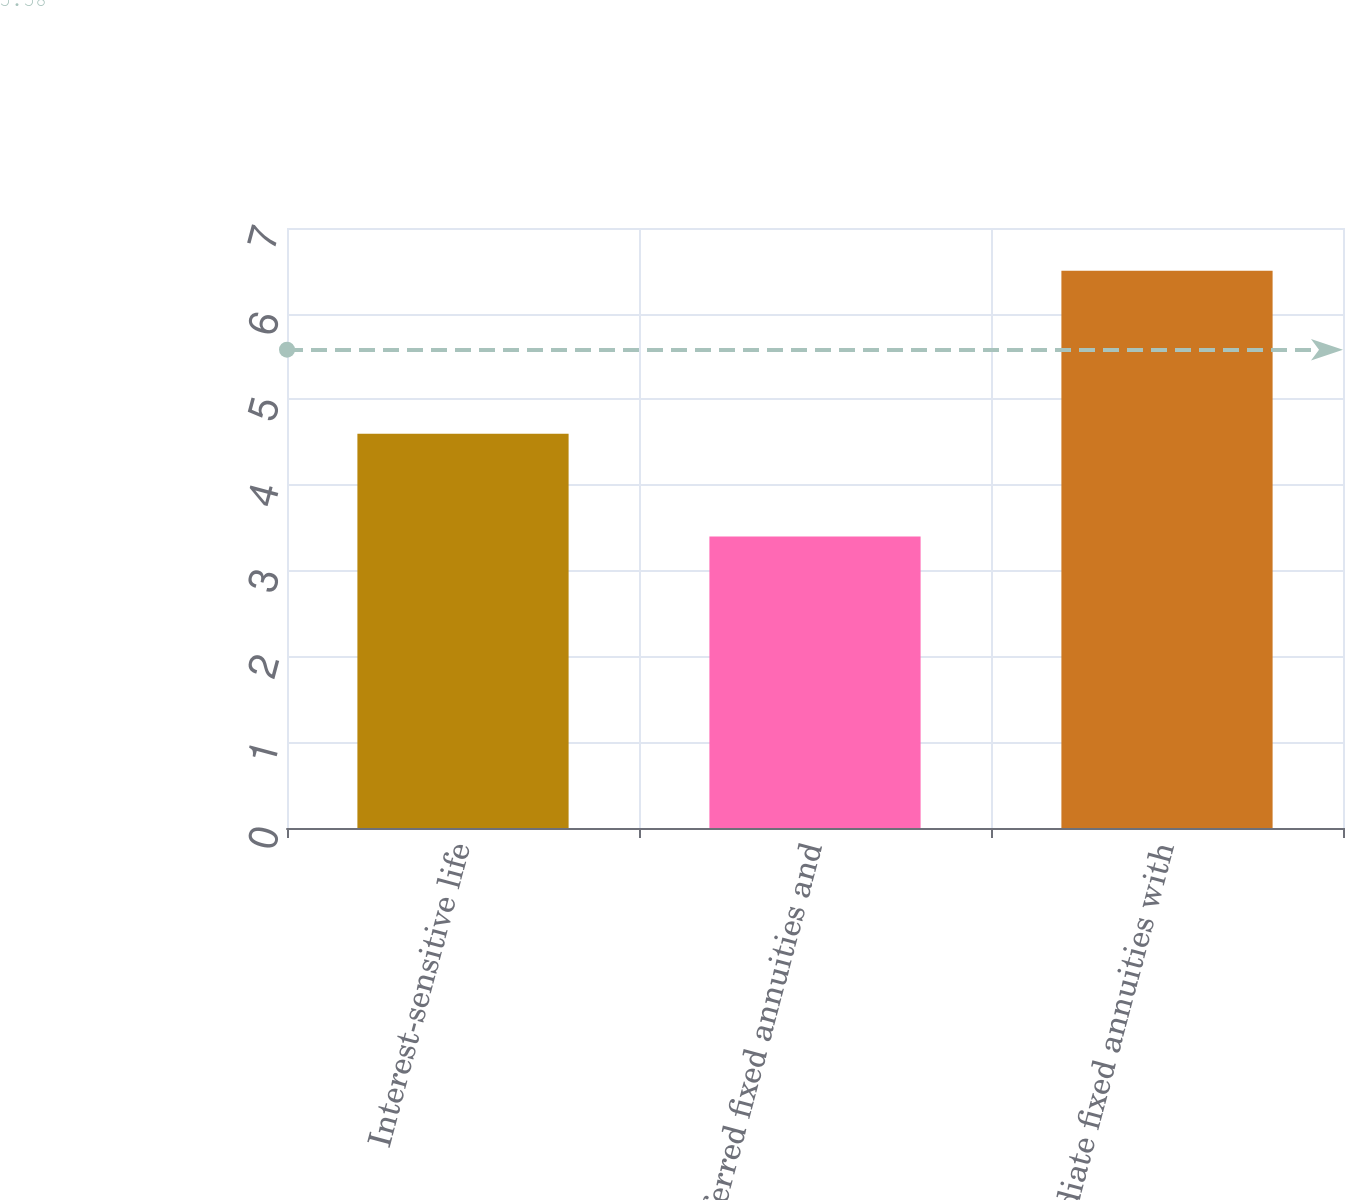Convert chart to OTSL. <chart><loc_0><loc_0><loc_500><loc_500><bar_chart><fcel>Interest-sensitive life<fcel>Deferred fixed annuities and<fcel>Immediate fixed annuities with<nl><fcel>4.6<fcel>3.4<fcel>6.5<nl></chart> 